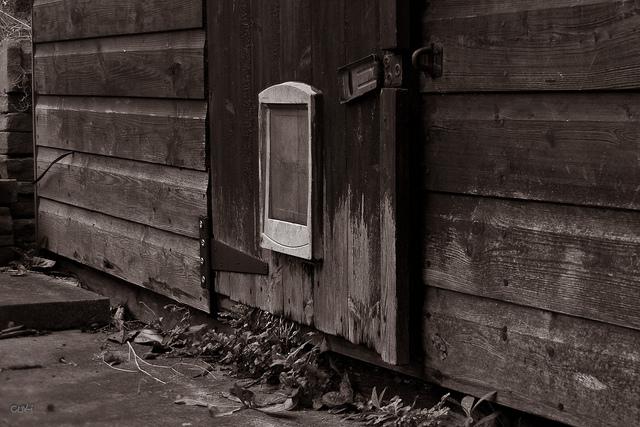What are the walls made of?
Be succinct. Wood. What is on the door?
Be succinct. Pet door. What is the building made of?
Concise answer only. Wood. Is the structure crumbling?
Answer briefly. Yes. Do you see any motorized vehicles?
Short answer required. No. Is that a balcony railing?
Write a very short answer. No. What material is the wall?
Quick response, please. Wood. 